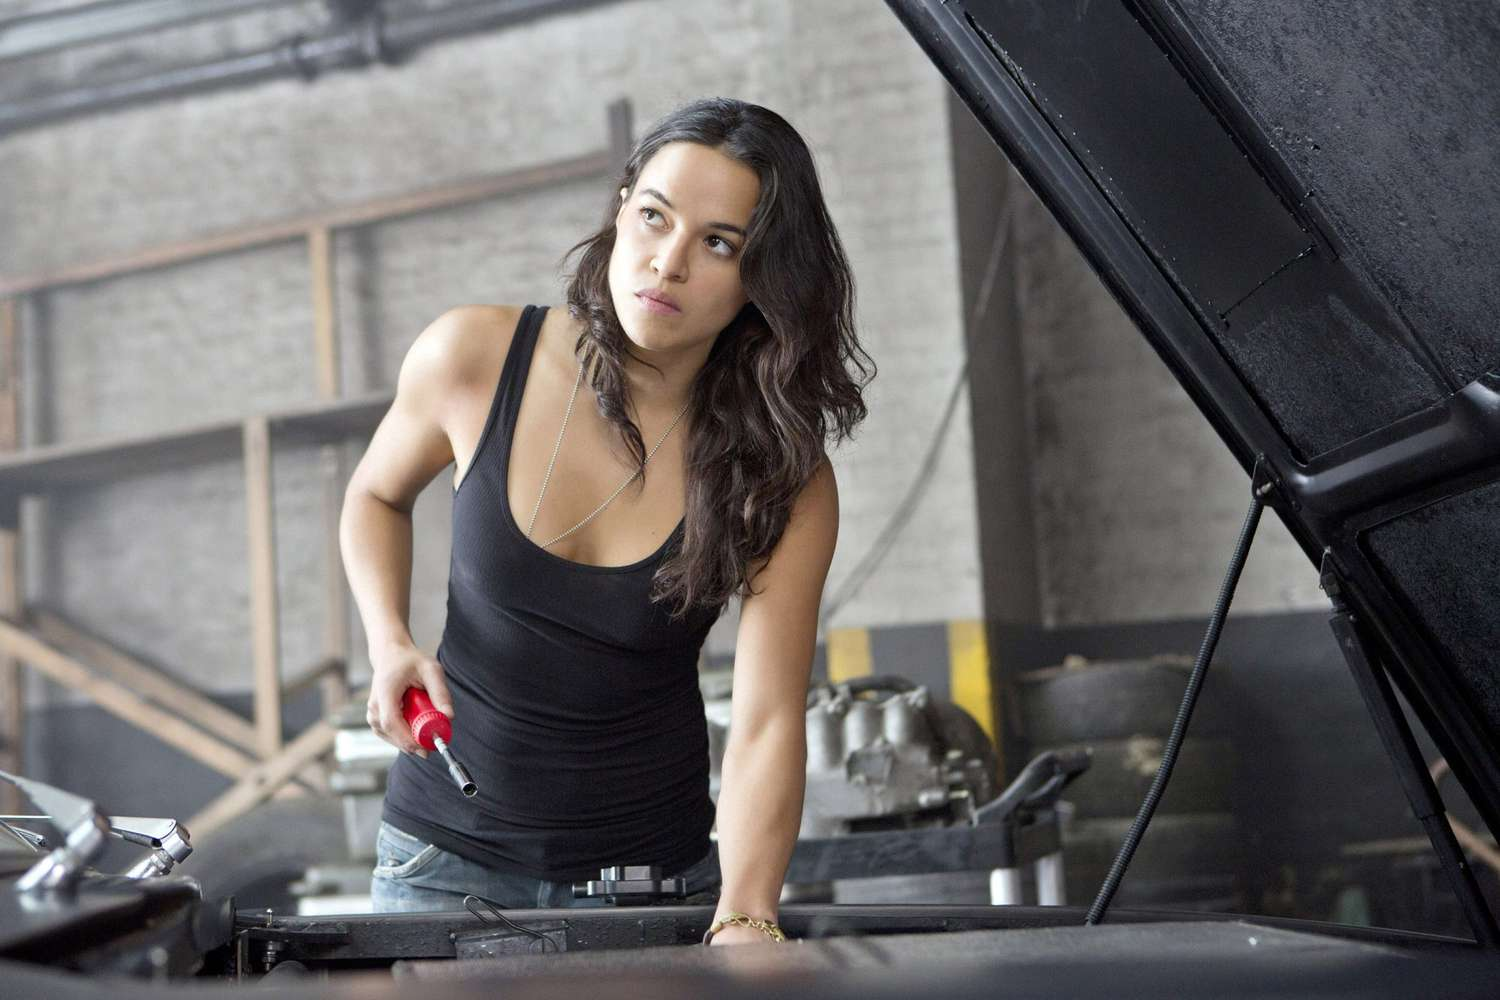Describe the surroundings of the woman in the garage. The garage setting is utilitarian with exposed brick walls and large, open spaces that are typical for vehicle maintenance. You can see various automotive parts and tools scattered around, which adds to the authenticity of a working garage environment. 